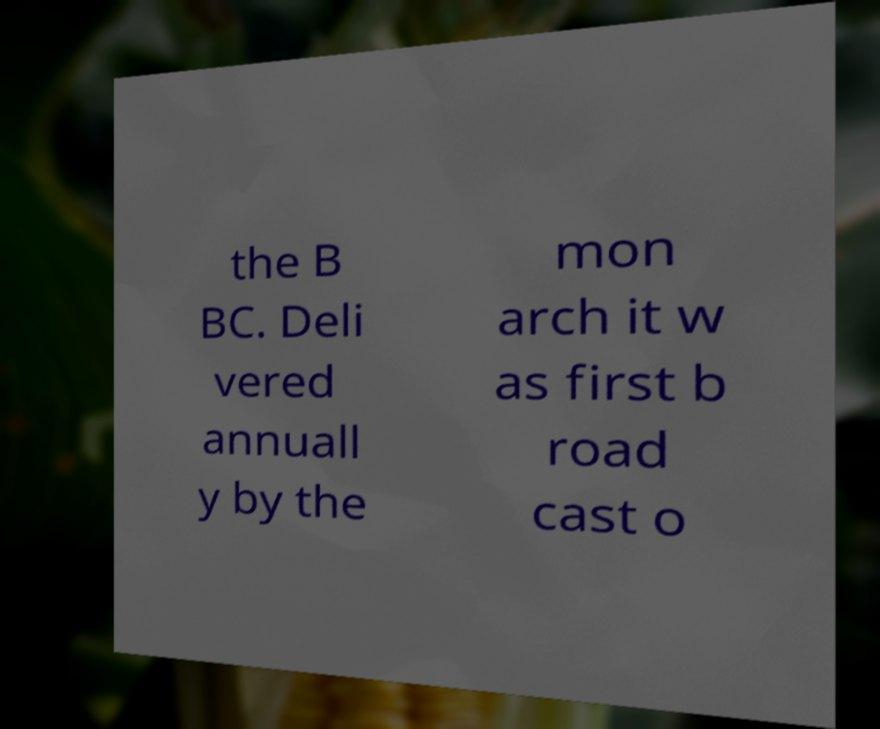Please read and relay the text visible in this image. What does it say? the B BC. Deli vered annuall y by the mon arch it w as first b road cast o 